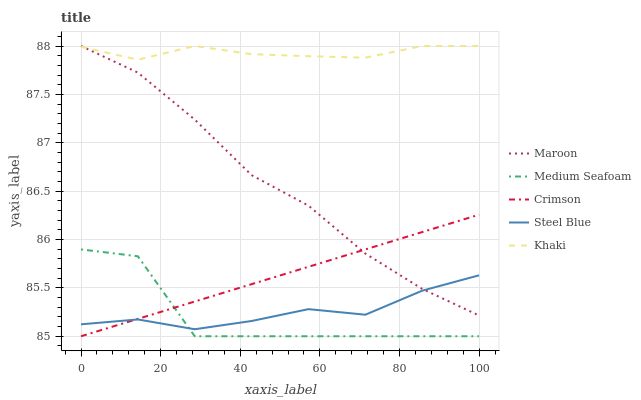Does Medium Seafoam have the minimum area under the curve?
Answer yes or no. Yes. Does Khaki have the maximum area under the curve?
Answer yes or no. Yes. Does Khaki have the minimum area under the curve?
Answer yes or no. No. Does Medium Seafoam have the maximum area under the curve?
Answer yes or no. No. Is Crimson the smoothest?
Answer yes or no. Yes. Is Medium Seafoam the roughest?
Answer yes or no. Yes. Is Khaki the smoothest?
Answer yes or no. No. Is Khaki the roughest?
Answer yes or no. No. Does Crimson have the lowest value?
Answer yes or no. Yes. Does Khaki have the lowest value?
Answer yes or no. No. Does Maroon have the highest value?
Answer yes or no. Yes. Does Medium Seafoam have the highest value?
Answer yes or no. No. Is Crimson less than Khaki?
Answer yes or no. Yes. Is Khaki greater than Medium Seafoam?
Answer yes or no. Yes. Does Steel Blue intersect Medium Seafoam?
Answer yes or no. Yes. Is Steel Blue less than Medium Seafoam?
Answer yes or no. No. Is Steel Blue greater than Medium Seafoam?
Answer yes or no. No. Does Crimson intersect Khaki?
Answer yes or no. No. 